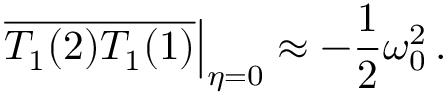Convert formula to latex. <formula><loc_0><loc_0><loc_500><loc_500>\overline { { T _ { 1 } ( 2 ) T _ { 1 } ( 1 ) } } \right | _ { \eta = 0 } \approx - \frac { 1 } { 2 } \omega _ { 0 } ^ { 2 } \, .</formula> 